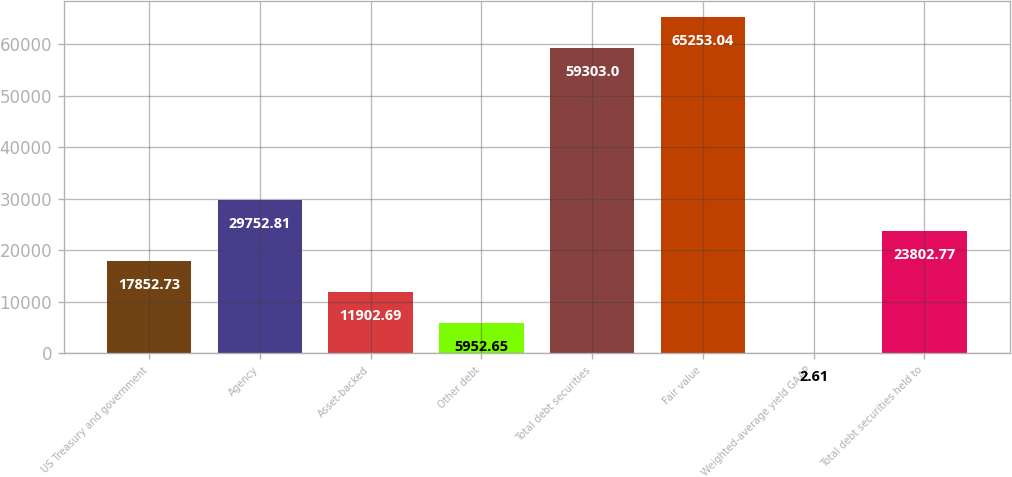<chart> <loc_0><loc_0><loc_500><loc_500><bar_chart><fcel>US Treasury and government<fcel>Agency<fcel>Asset-backed<fcel>Other debt<fcel>Total debt securities<fcel>Fair value<fcel>Weighted-average yield GAAP<fcel>Total debt securities held to<nl><fcel>17852.7<fcel>29752.8<fcel>11902.7<fcel>5952.65<fcel>59303<fcel>65253<fcel>2.61<fcel>23802.8<nl></chart> 